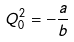Convert formula to latex. <formula><loc_0><loc_0><loc_500><loc_500>Q _ { 0 } ^ { 2 } = - \frac { a } { b }</formula> 